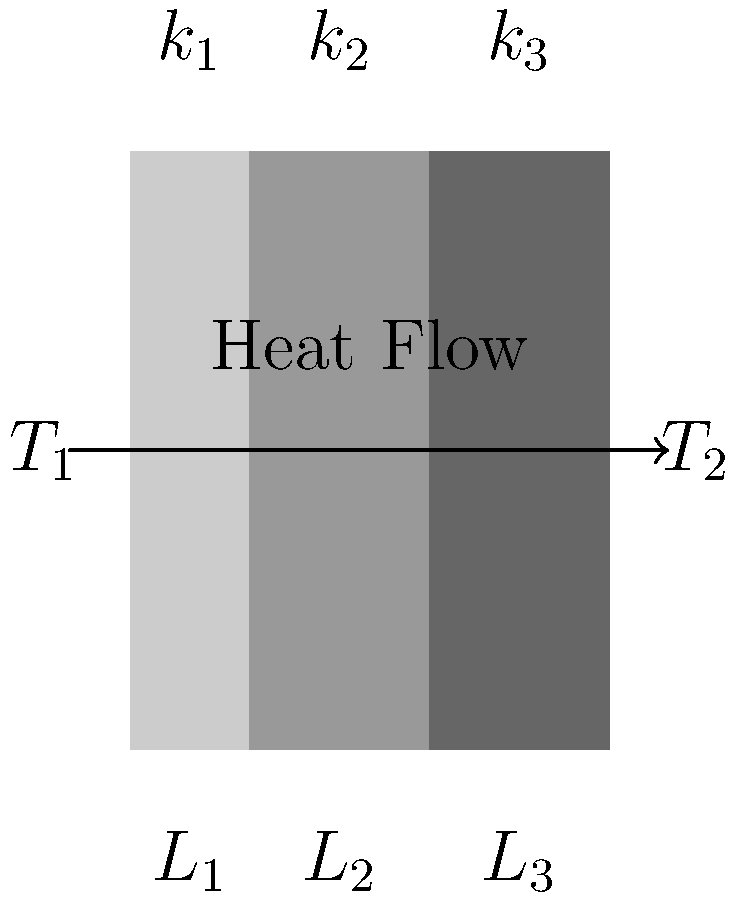In your studies of sacred architecture, you've encountered a multi-layered wall in an ancient temple. The wall consists of three layers with thermal conductivities $k_1$, $k_2$, and $k_3$, and thicknesses $L_1$, $L_2$, and $L_3$ respectively. If the temperature difference between the inner and outer surfaces is $\Delta T = T_1 - T_2$, what is the expression for the total heat flux through the wall in terms of these variables? To solve this problem, we'll use the concept of thermal resistance in series, which is analogous to electrical resistance. Here's a step-by-step approach:

1) The heat flux (q) through each layer is the same and equal to the total heat flux.

2) For each layer, the heat flux is given by Fourier's law:
   $q = -k \frac{dT}{dx}$

3) In steady-state, this can be written as:
   $q = k \frac{\Delta T}{L}$

4) The temperature difference across the entire wall is the sum of the temperature differences across each layer:
   $\Delta T = \Delta T_1 + \Delta T_2 + \Delta T_3$

5) We can express each $\Delta T_i$ in terms of q:
   $\Delta T_1 = \frac{qL_1}{k_1}$, $\Delta T_2 = \frac{qL_2}{k_2}$, $\Delta T_3 = \frac{qL_3}{k_3}$

6) Substituting these into the equation from step 4:
   $\Delta T = \frac{qL_1}{k_1} + \frac{qL_2}{k_2} + \frac{qL_3}{k_3}$

7) Factoring out q:
   $\Delta T = q(\frac{L_1}{k_1} + \frac{L_2}{k_2} + \frac{L_3}{k_3})$

8) Solving for q:
   $q = \frac{\Delta T}{\frac{L_1}{k_1} + \frac{L_2}{k_2} + \frac{L_3}{k_3}}$

This expression gives the total heat flux through the multi-layered wall.
Answer: $q = \frac{\Delta T}{\frac{L_1}{k_1} + \frac{L_2}{k_2} + \frac{L_3}{k_3}}$ 